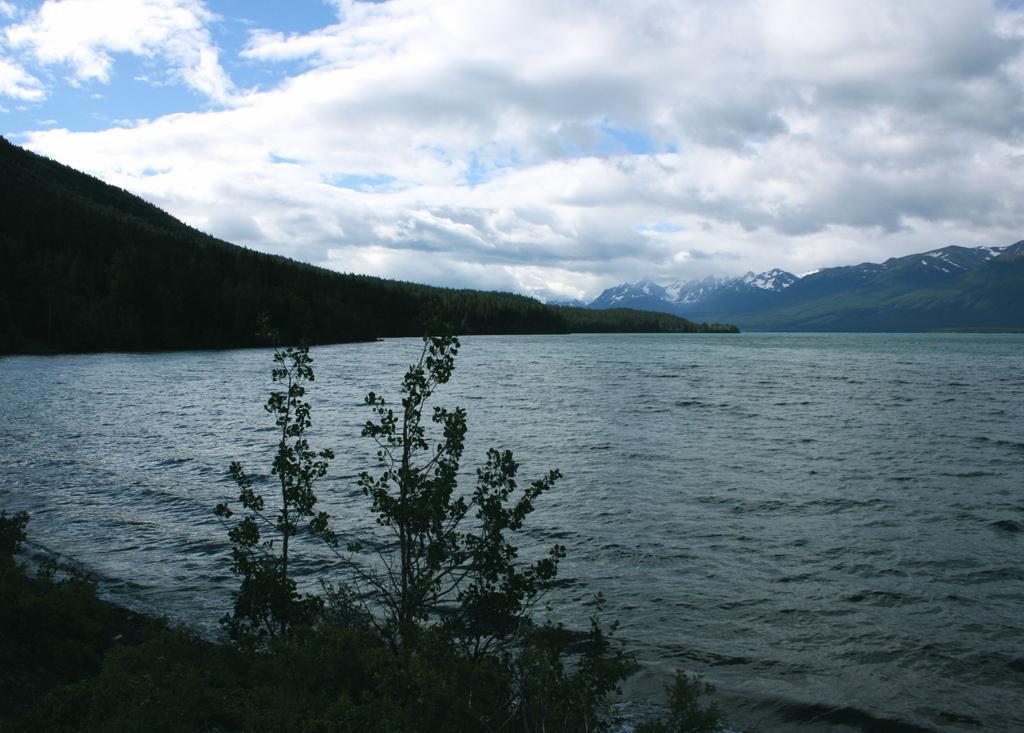How would you summarize this image in a sentence or two? In this image we can see water and in front of the water we can see few plants. Behind the water we can see mountains. At the top we can see the clear sky. 